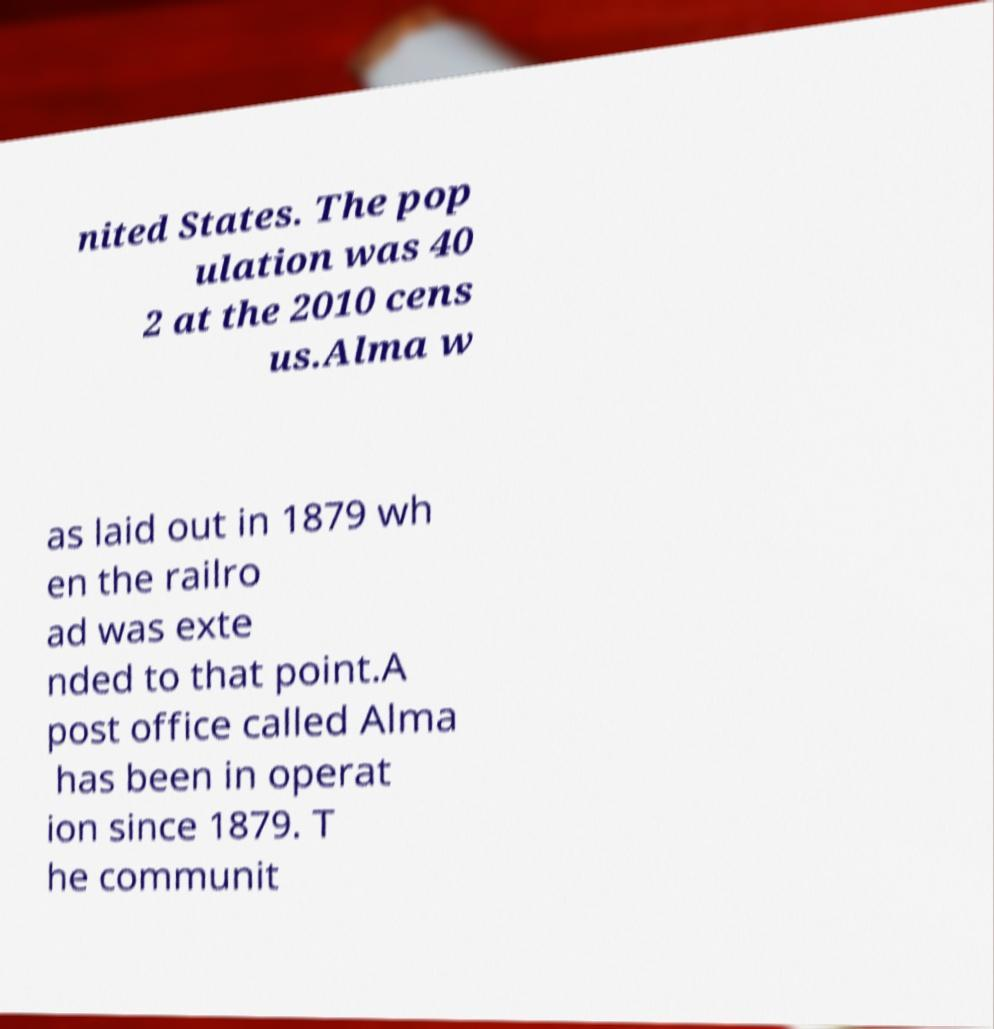What messages or text are displayed in this image? I need them in a readable, typed format. nited States. The pop ulation was 40 2 at the 2010 cens us.Alma w as laid out in 1879 wh en the railro ad was exte nded to that point.A post office called Alma has been in operat ion since 1879. T he communit 